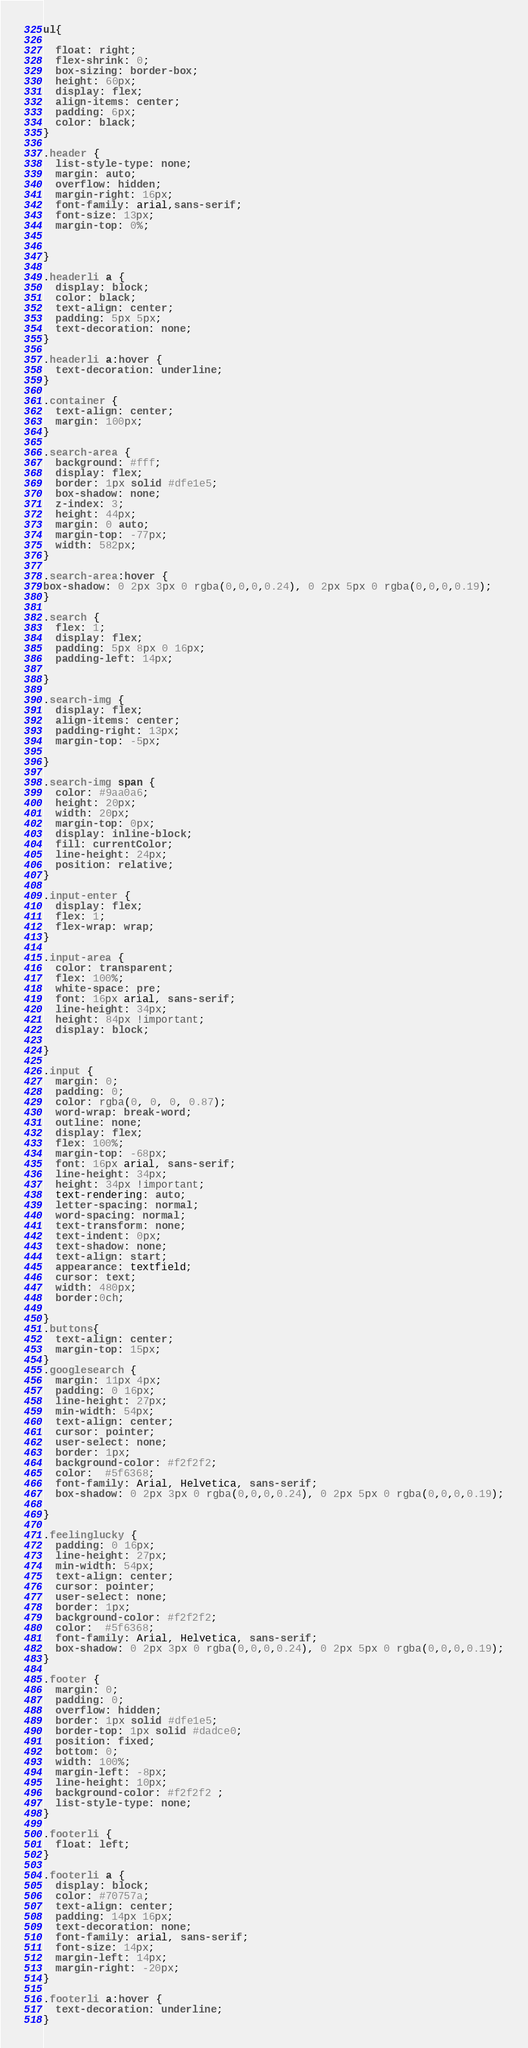<code> <loc_0><loc_0><loc_500><loc_500><_CSS_>ul{

  float: right;
  flex-shrink: 0;
  box-sizing: border-box;
  height: 60px;
  display: flex;
  align-items: center;
  padding: 6px;
  color: black;
}

.header {
  list-style-type: none;
  margin: auto;
  overflow: hidden;
  margin-right: 16px;
  font-family: arial,sans-serif;
  font-size: 13px;
  margin-top: 0%;
 
  
}

.headerli a {
  display: block;
  color: black;
  text-align: center;
  padding: 5px 5px;
  text-decoration: none;
}

.headerli a:hover {
  text-decoration: underline;
}

.container {
  text-align: center;
  margin: 100px;
}

.search-area {
  background: #fff;
  display: flex;
  border: 1px solid #dfe1e5;
  box-shadow: none;
  z-index: 3;
  height: 44px;
  margin: 0 auto;
  margin-top: -77px;
  width: 582px;
}

.search-area:hover {
box-shadow: 0 2px 3px 0 rgba(0,0,0,0.24), 0 2px 5px 0 rgba(0,0,0,0.19);
}

.search {
  flex: 1;
  display: flex;
  padding: 5px 8px 0 16px;
  padding-left: 14px;
  
}

.search-img {
  display: flex;
  align-items: center;
  padding-right: 13px;
  margin-top: -5px;
  
}

.search-img span {
  color: #9aa0a6;
  height: 20px;
  width: 20px;
  margin-top: 0px;
  display: inline-block;
  fill: currentColor;
  line-height: 24px;
  position: relative;
}

.input-enter {
  display: flex;
  flex: 1;
  flex-wrap: wrap;
}

.input-area {
  color: transparent;
  flex: 100%;
  white-space: pre;
  font: 16px arial, sans-serif;
  line-height: 34px;
  height: 84px !important;
  display: block;
  
}

.input {
  margin: 0;
  padding: 0;
  color: rgba(0, 0, 0, 0.87);
  word-wrap: break-word;
  outline: none;
  display: flex;
  flex: 100%;
  margin-top: -68px;
  font: 16px arial, sans-serif;
  line-height: 34px;
  height: 34px !important;
  text-rendering: auto;
  letter-spacing: normal;
  word-spacing: normal;
  text-transform: none;
  text-indent: 0px;
  text-shadow: none;
  text-align: start;
  appearance: textfield;
  cursor: text;
  width: 480px;
  border:0ch;
  
}
.buttons{
  text-align: center;
  margin-top: 15px;
}
.googlesearch {
  margin: 11px 4px;
  padding: 0 16px;
  line-height: 27px;
  min-width: 54px;
  text-align: center;
  cursor: pointer;
  user-select: none;
  border: 1px;
  background-color: #f2f2f2;
  color:  #5f6368;
  font-family: Arial, Helvetica, sans-serif;
  box-shadow: 0 2px 3px 0 rgba(0,0,0,0.24), 0 2px 5px 0 rgba(0,0,0,0.19);
  
}

.feelinglucky {
  padding: 0 16px;
  line-height: 27px;
  min-width: 54px;
  text-align: center;
  cursor: pointer;
  user-select: none;
  border: 1px;
  background-color: #f2f2f2;
  color:  #5f6368;
  font-family: Arial, Helvetica, sans-serif;
  box-shadow: 0 2px 3px 0 rgba(0,0,0,0.24), 0 2px 5px 0 rgba(0,0,0,0.19);
}

.footer {
  margin: 0;
  padding: 0;
  overflow: hidden;
  border: 1px solid #dfe1e5;
  border-top: 1px solid #dadce0;
  position: fixed;
  bottom: 0;
  width: 100%;
  margin-left: -8px;
  line-height: 10px;
  background-color: #f2f2f2 ;
  list-style-type: none;
}

.footerli {
  float: left;
}

.footerli a {
  display: block;
  color: #70757a;
  text-align: center;
  padding: 14px 16px;
  text-decoration: none;
  font-family: arial, sans-serif;
  font-size: 14px;
  margin-left: 14px;
  margin-right: -20px;
}

.footerli a:hover {
  text-decoration: underline;
}
</code> 